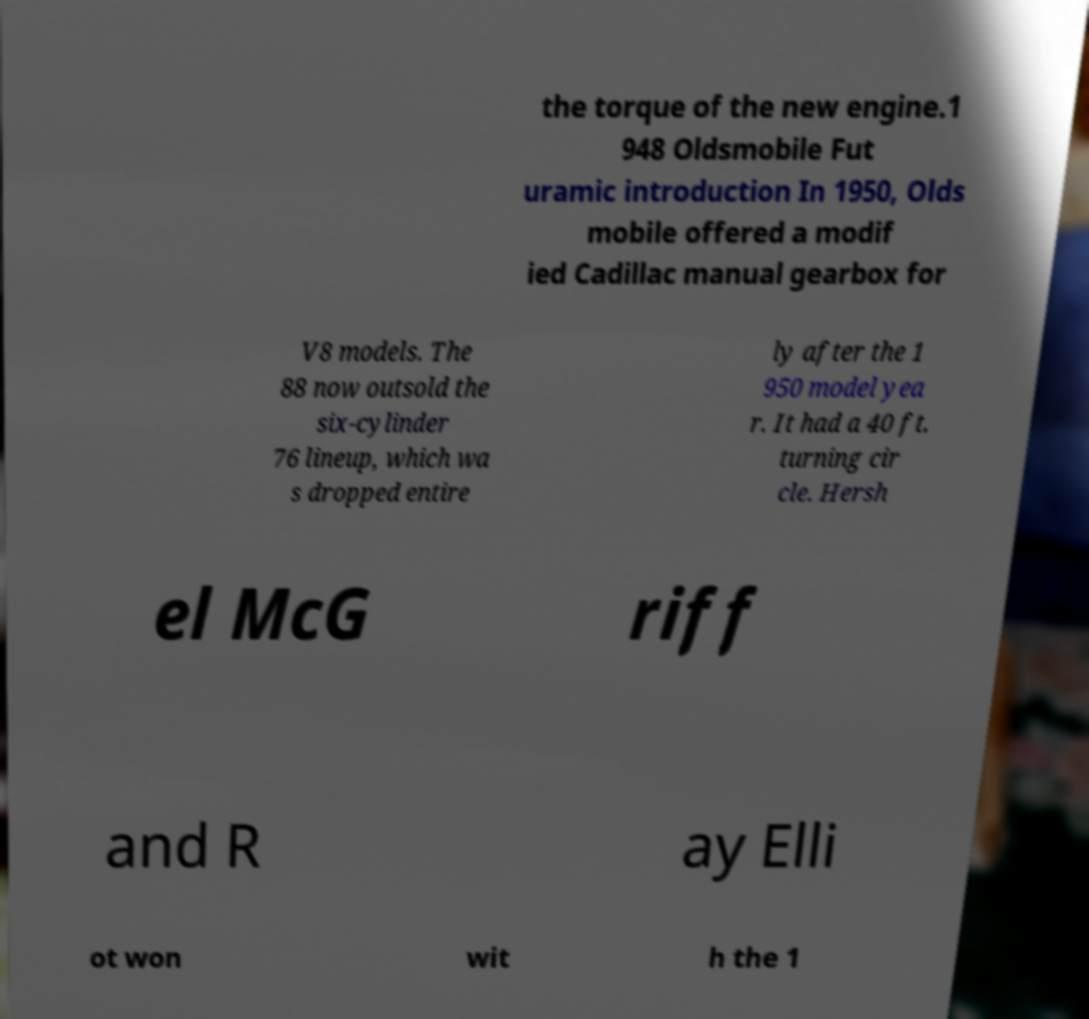What messages or text are displayed in this image? I need them in a readable, typed format. the torque of the new engine.1 948 Oldsmobile Fut uramic introduction In 1950, Olds mobile offered a modif ied Cadillac manual gearbox for V8 models. The 88 now outsold the six-cylinder 76 lineup, which wa s dropped entire ly after the 1 950 model yea r. It had a 40 ft. turning cir cle. Hersh el McG riff and R ay Elli ot won wit h the 1 